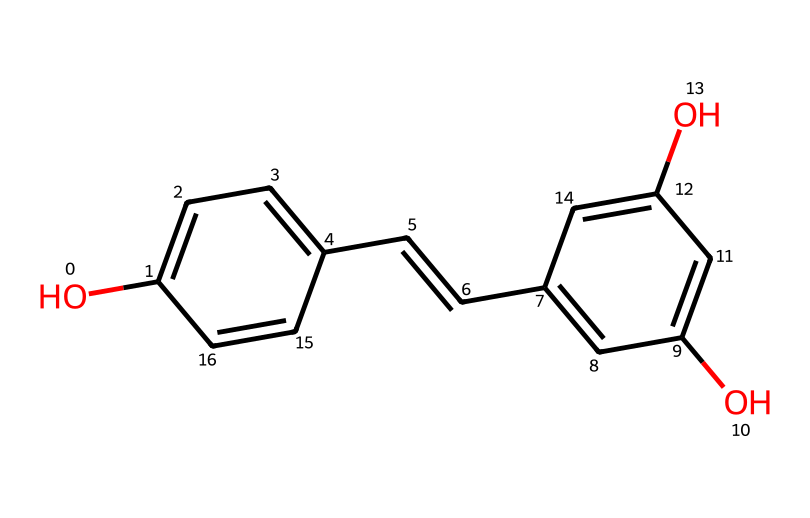What is the main functional group present in resveratrol? The chemical structure shows multiple hydroxyl (-OH) groups attached to the aromatic rings, which classifies them as phenolic compounds. The presence of these groups is essential for its antioxidant activity.
Answer: phenolic How many aromatic rings are present in the structure of resveratrol? By examining the chemical structure, we can see two distinct aromatic rings. Each ring is part of the overall polyphenolic nature of resveratrol.
Answer: two What is the total number of hydroxyl groups in resveratrol? The structure presents three hydroxyl groups (-OH) that are connected to the aromatic rings. Counting each -OH group in the structure indicates their total number.
Answer: three Which chemical element is primarily responsible for the antioxidant properties in resveratrol? The antioxidant properties arise mainly from the presence of the hydroxyl groups (-OH), which can scavenge free radicals. Their activities are key to the overall functionalities in antioxidants.
Answer: oxygen What type of isomerism can resveratrol exhibit due to its double bond? The presence of a cis/trans double bond in the chain of the structure allows for geometric isomerism, showcasing how the spatial arrangement affects its properties.
Answer: geometric What is the molecular formula of resveratrol based on its structure? By analyzing the number of carbons, hydrogens, and oxygens in the structure, you can compute it to C14H12O3. This formula summarizes the composition of the molecule.
Answer: C14H12O3 